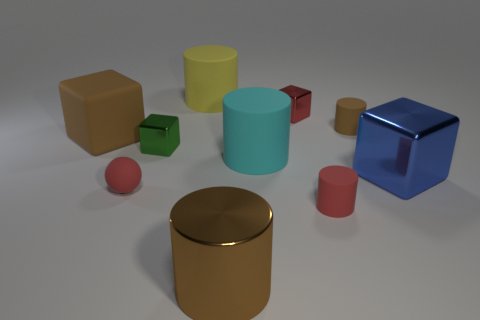How many other things are made of the same material as the small brown cylinder?
Your answer should be very brief. 5. What number of objects are either tiny matte cylinders in front of the cyan thing or tiny red rubber blocks?
Your answer should be very brief. 1. There is a brown object that is both behind the red matte cylinder and left of the tiny red cylinder; what is its shape?
Give a very brief answer. Cube. There is a red ball that is made of the same material as the large cyan object; what is its size?
Keep it short and to the point. Small. What number of things are large cylinders that are behind the small brown matte object or matte things to the right of the yellow rubber thing?
Keep it short and to the point. 4. Is the size of the shiny block behind the matte cube the same as the large rubber cube?
Keep it short and to the point. No. The metallic cube left of the large yellow object is what color?
Ensure brevity in your answer.  Green. There is a large metal thing that is the same shape as the big yellow matte object; what is its color?
Provide a short and direct response. Brown. There is a big metal object in front of the small matte cylinder in front of the tiny red ball; how many brown cylinders are behind it?
Offer a terse response. 1. Is the number of matte blocks to the right of the brown metallic cylinder less than the number of red shiny objects?
Your answer should be compact. Yes. 